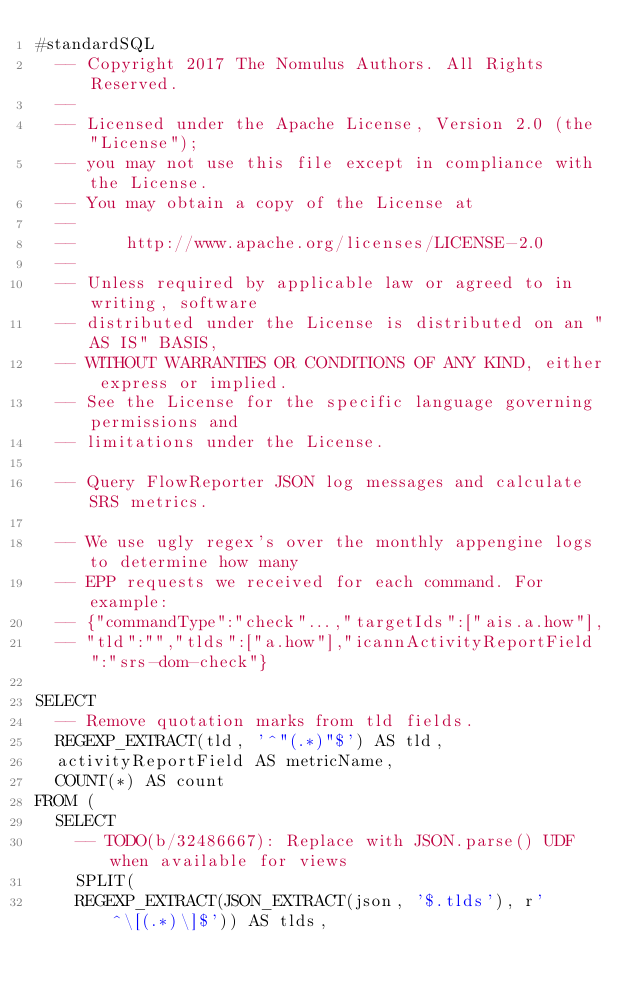<code> <loc_0><loc_0><loc_500><loc_500><_SQL_>#standardSQL
  -- Copyright 2017 The Nomulus Authors. All Rights Reserved.
  --
  -- Licensed under the Apache License, Version 2.0 (the "License");
  -- you may not use this file except in compliance with the License.
  -- You may obtain a copy of the License at
  --
  --     http://www.apache.org/licenses/LICENSE-2.0
  --
  -- Unless required by applicable law or agreed to in writing, software
  -- distributed under the License is distributed on an "AS IS" BASIS,
  -- WITHOUT WARRANTIES OR CONDITIONS OF ANY KIND, either express or implied.
  -- See the License for the specific language governing permissions and
  -- limitations under the License.

  -- Query FlowReporter JSON log messages and calculate SRS metrics.

  -- We use ugly regex's over the monthly appengine logs to determine how many
  -- EPP requests we received for each command. For example:
  -- {"commandType":"check"...,"targetIds":["ais.a.how"],
  -- "tld":"","tlds":["a.how"],"icannActivityReportField":"srs-dom-check"}

SELECT
  -- Remove quotation marks from tld fields.
  REGEXP_EXTRACT(tld, '^"(.*)"$') AS tld,
  activityReportField AS metricName,
  COUNT(*) AS count
FROM (
  SELECT
    -- TODO(b/32486667): Replace with JSON.parse() UDF when available for views
    SPLIT(
    REGEXP_EXTRACT(JSON_EXTRACT(json, '$.tlds'), r'^\[(.*)\]$')) AS tlds,</code> 